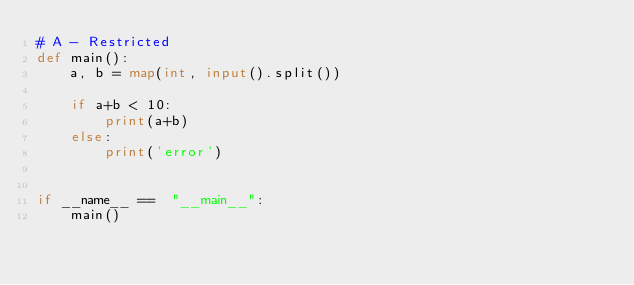Convert code to text. <code><loc_0><loc_0><loc_500><loc_500><_Python_># A - Restricted
def main():
    a, b = map(int, input().split())

    if a+b < 10:
        print(a+b)
    else:
        print('error')


if __name__ ==  "__main__":
    main()</code> 